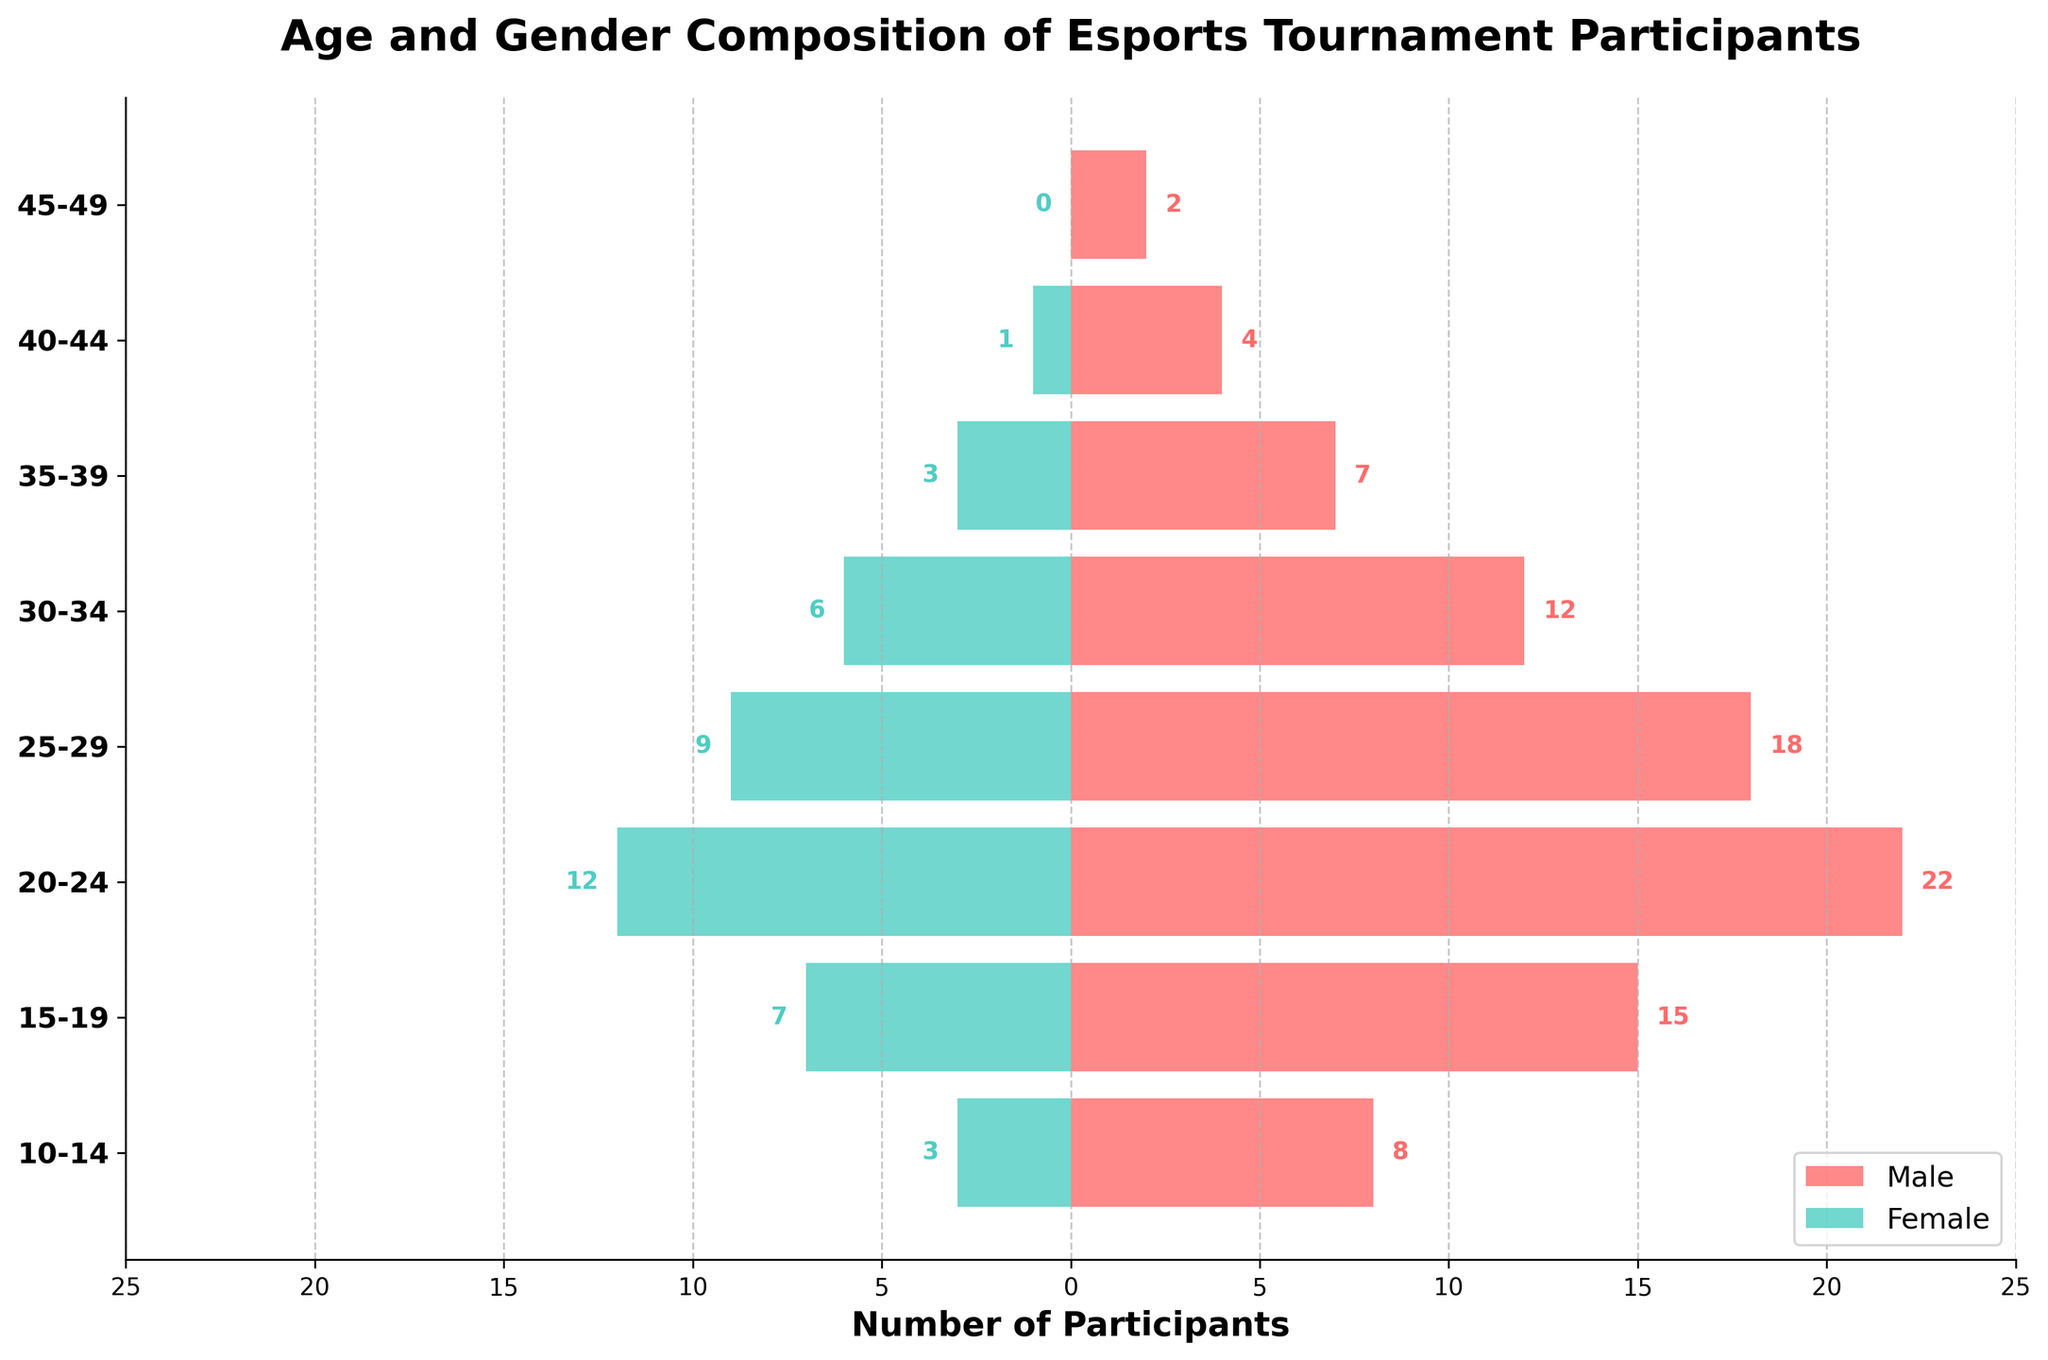what is the title of the plot? The title is typically found at the top of the figure and provides an overview of what the plot represents. The title in this figure is "Age and Gender Composition of Esports Tournament Participants".
Answer: Age and Gender Composition of Esports Tournament Participants What is the age group with the highest number of male participants? Identify the bar representing the highest value on the male side (right side of the plot)
Answer: 20-24 How many female participants are in the 35-39 age group? Locate the bar corresponding to the 35-39 age group and look at its length towards the female side (left side of the plot). The plot shows the number 3.
Answer: 3 What's the difference in the number of participants between the 15-19 and 25-29 age groups for males? Subtract the number of male participants in the 25-29 age group from the number of male participants in the 15-19 age group: 15 - 18
Answer: 3 Which age group has more female participants, 10-14 or 30-34? Compare the lengths of the female bars for the 10-14 and 30-34 age groups. The 30-34 group has a longer bar indicating more participants.
Answer: 30-34 In the 20-24 age group, what is the ratio of male to female participants? The number of male participants in the 20-24 age group is 22, and the number of female participants is 12. Divide the number of males by the number of females: 22/12
Answer: 11/6 What is the total number of participants in the 40-44 age group? Add the number of male and female participants in the 40-44 age group: 4 males + 1 female
Answer: 5 What's the combined number of participants in the 15-19 and 10-14 age groups? Sum the male and female participants in both age groups: (15+7+8+3)
Answer: 33 How does the number of female participants in the 25-29 age group compare to that in the 40-44 age group? Compare the lengths of the female bars for the two age groups. The 25-29 age group has more female participants (9 vs 1).
Answer: 25-29 has more Which gender has more participants overall in this tournament? Sum the total number of male participants and female participants across all age groups. Compare the sums to determine which gender has more participants. The sum for males is 88 and for females is 41.
Answer: Male 